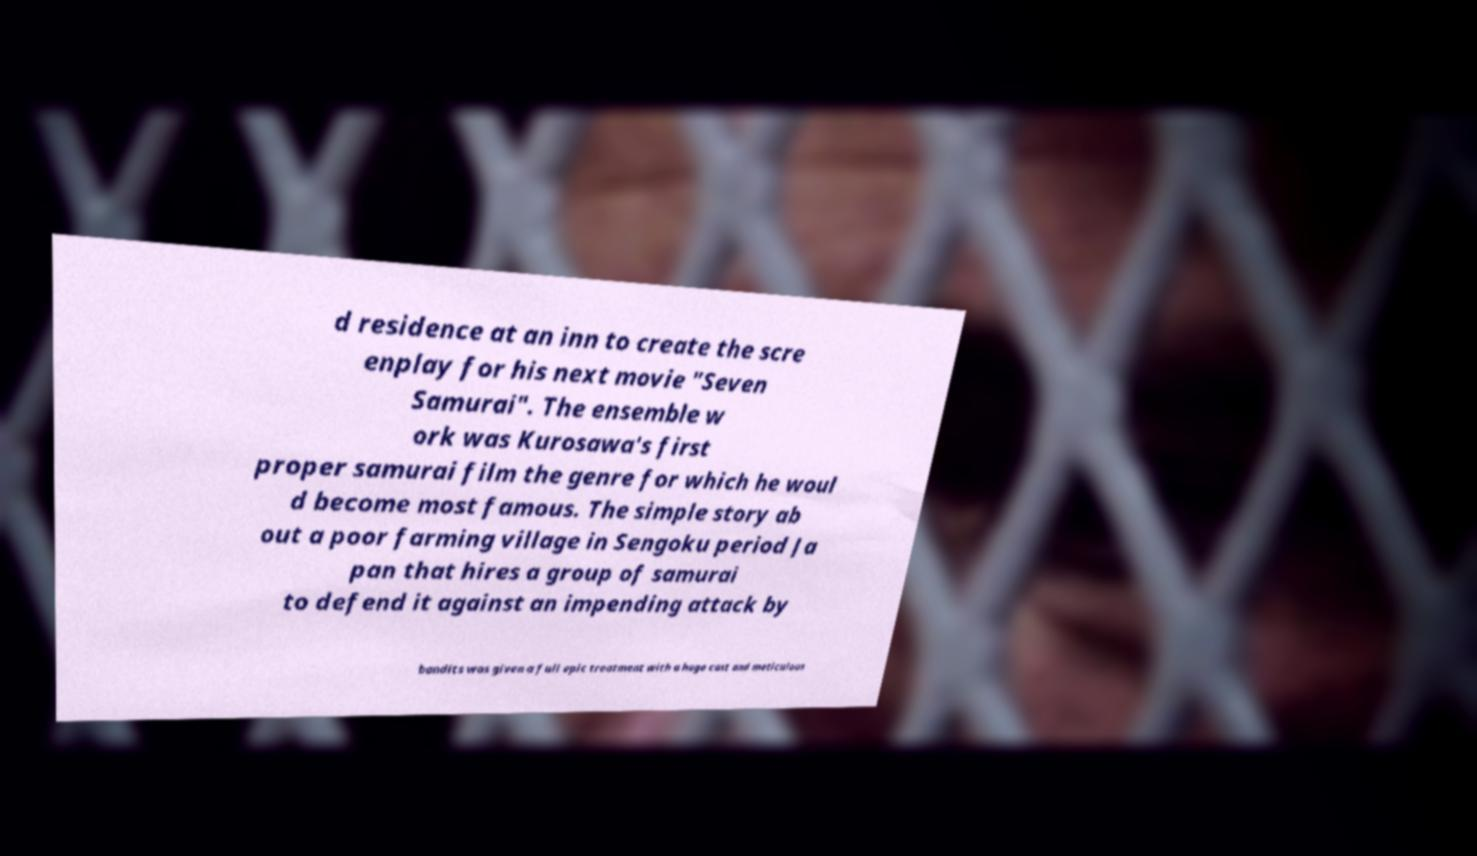Please read and relay the text visible in this image. What does it say? d residence at an inn to create the scre enplay for his next movie "Seven Samurai". The ensemble w ork was Kurosawa's first proper samurai film the genre for which he woul d become most famous. The simple story ab out a poor farming village in Sengoku period Ja pan that hires a group of samurai to defend it against an impending attack by bandits was given a full epic treatment with a huge cast and meticulous 